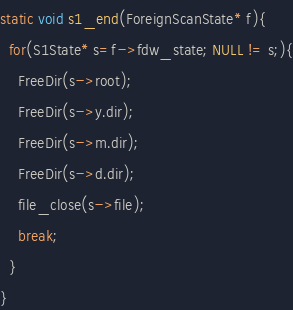Convert code to text. <code><loc_0><loc_0><loc_500><loc_500><_C_>
static void s1_end(ForeignScanState* f){
  for(S1State* s=f->fdw_state; NULL != s;){
    FreeDir(s->root);
    FreeDir(s->y.dir);
    FreeDir(s->m.dir);
    FreeDir(s->d.dir);
    file_close(s->file);
    break;
  }
}
</code> 